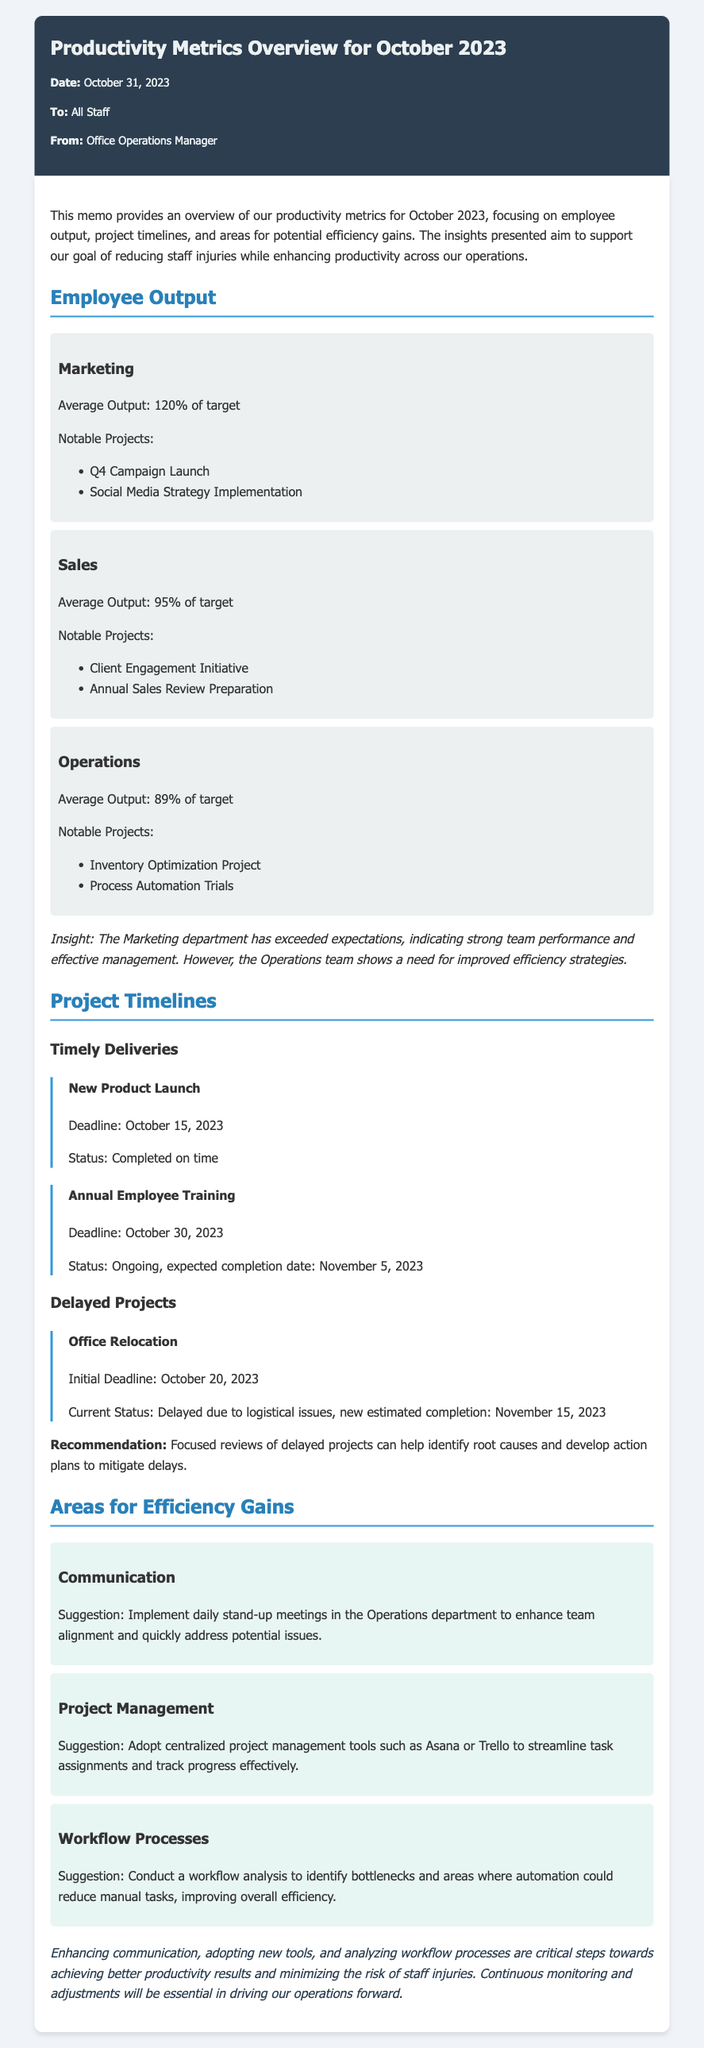What is the average output of the Marketing department? The average output of the Marketing department is stated as 120% of target in the document.
Answer: 120% of target What is the completion status of the New Product Launch project? The document specifies that the New Product Launch project was completed on time.
Answer: Completed on time Which department has shown a need for improved efficiency strategies? The document mentions that the Operations team shows a need for improved efficiency strategies.
Answer: Operations What is the initial deadline for the Office Relocation project? The initial deadline for the Office Relocation project is noted as October 20, 2023 in the memo.
Answer: October 20, 2023 What suggestion is made to enhance communication in the Operations department? The document suggests implementing daily stand-up meetings in the Operations department to enhance communication.
Answer: Daily stand-up meetings How many notable projects are listed for the Sales department? The Sales department has two notable projects listed in the document.
Answer: Two What is the expected completion date for the Annual Employee Training? The expected completion date for the Annual Employee Training is November 5, 2023 according to the document.
Answer: November 5, 2023 Which tool is recommended for centralized project management? The memo recommends using tools such as Asana or Trello for centralized project management.
Answer: Asana or Trello What is the overall goal of the insights presented in the memo? The overall goal is to support reducing staff injuries while enhancing productivity across operations.
Answer: Reducing staff injuries and enhancing productivity 